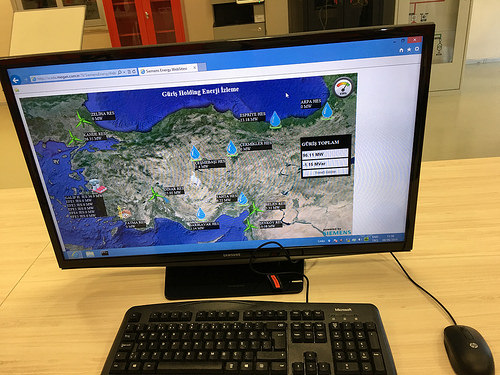<image>
Is there a monitor behind the mouse? Yes. From this viewpoint, the monitor is positioned behind the mouse, with the mouse partially or fully occluding the monitor. 